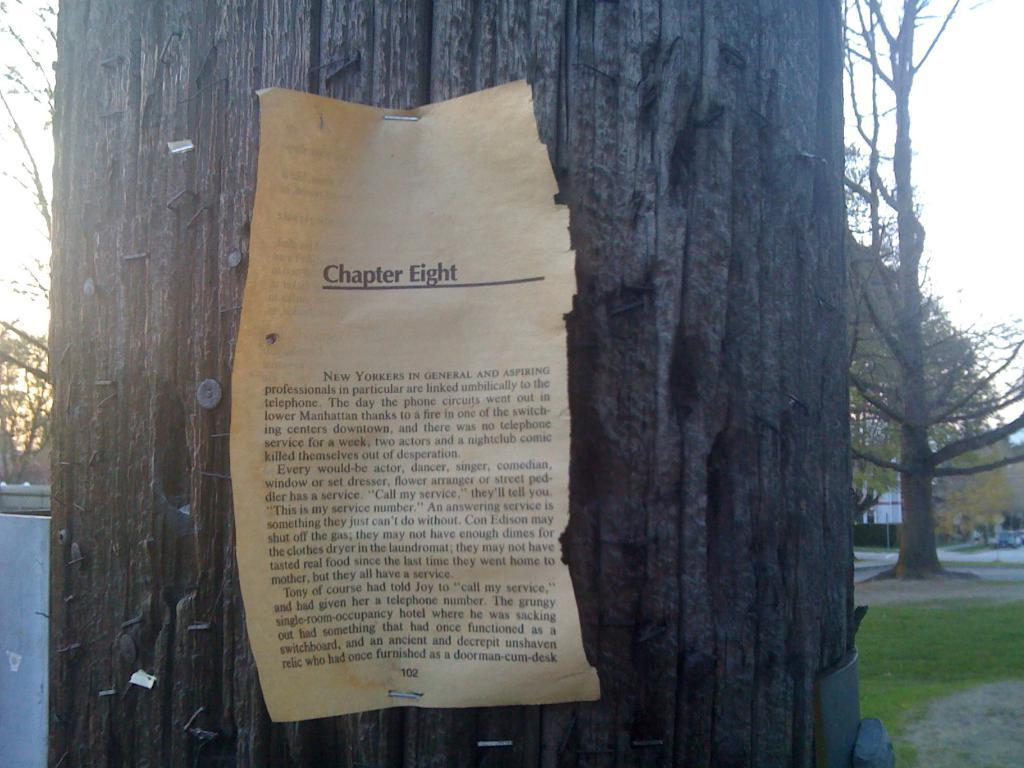What is placed on the tree trunk in the image? There is a paper on a tree trunk in the image. What type of vegetation can be seen in the image? There is grass and trees visible in the image. What is the primary mode of transportation visible in the image? There is a car on the road in the image. What part of the natural environment is visible in the background of the image? The sky is visible in the background of the image. How many lizards are present in the image? There are no lizards present in the image. What type of pollution is visible in the image? There is no visible pollution in the image. 